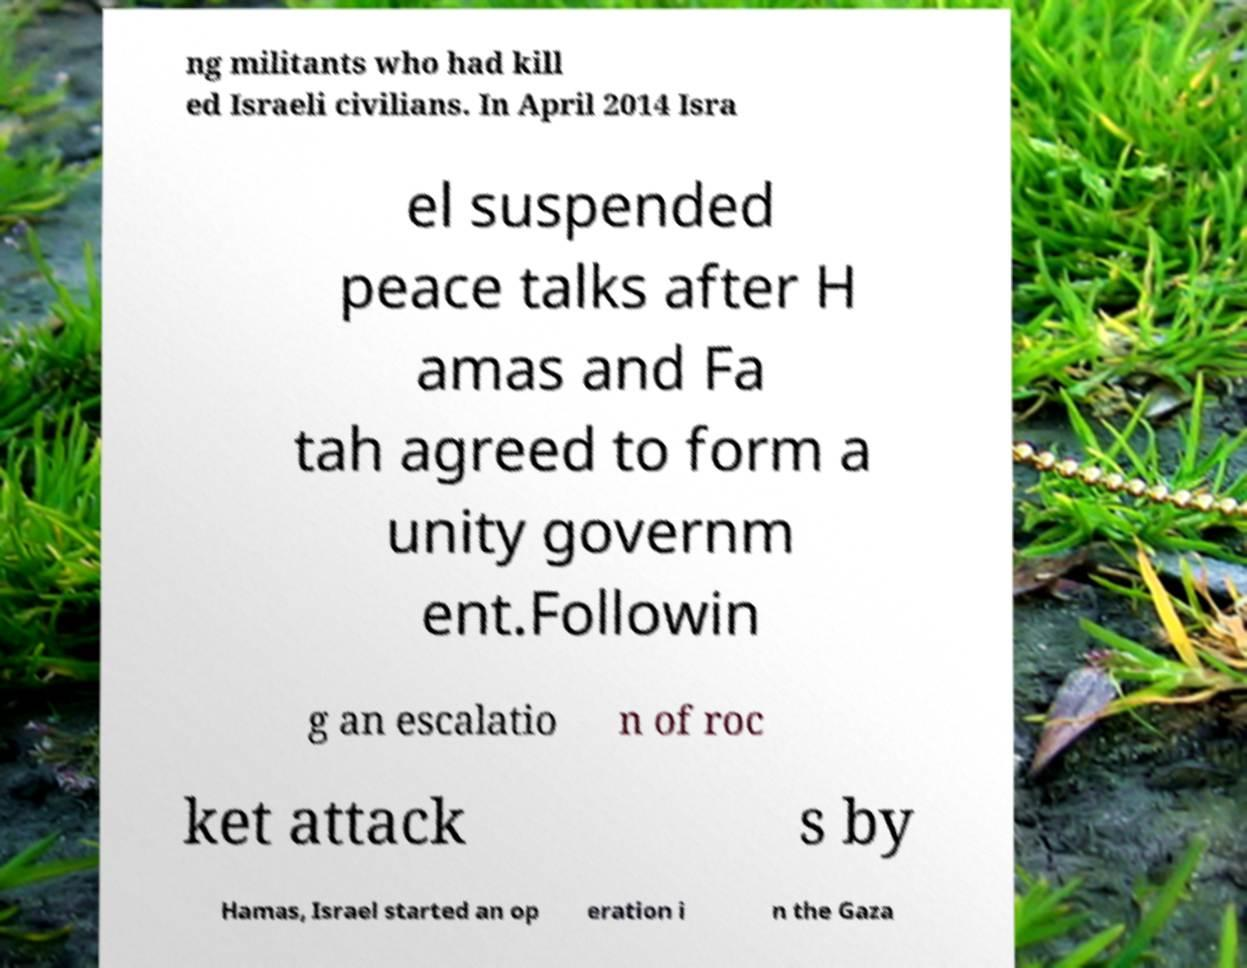There's text embedded in this image that I need extracted. Can you transcribe it verbatim? ng militants who had kill ed Israeli civilians. In April 2014 Isra el suspended peace talks after H amas and Fa tah agreed to form a unity governm ent.Followin g an escalatio n of roc ket attack s by Hamas, Israel started an op eration i n the Gaza 